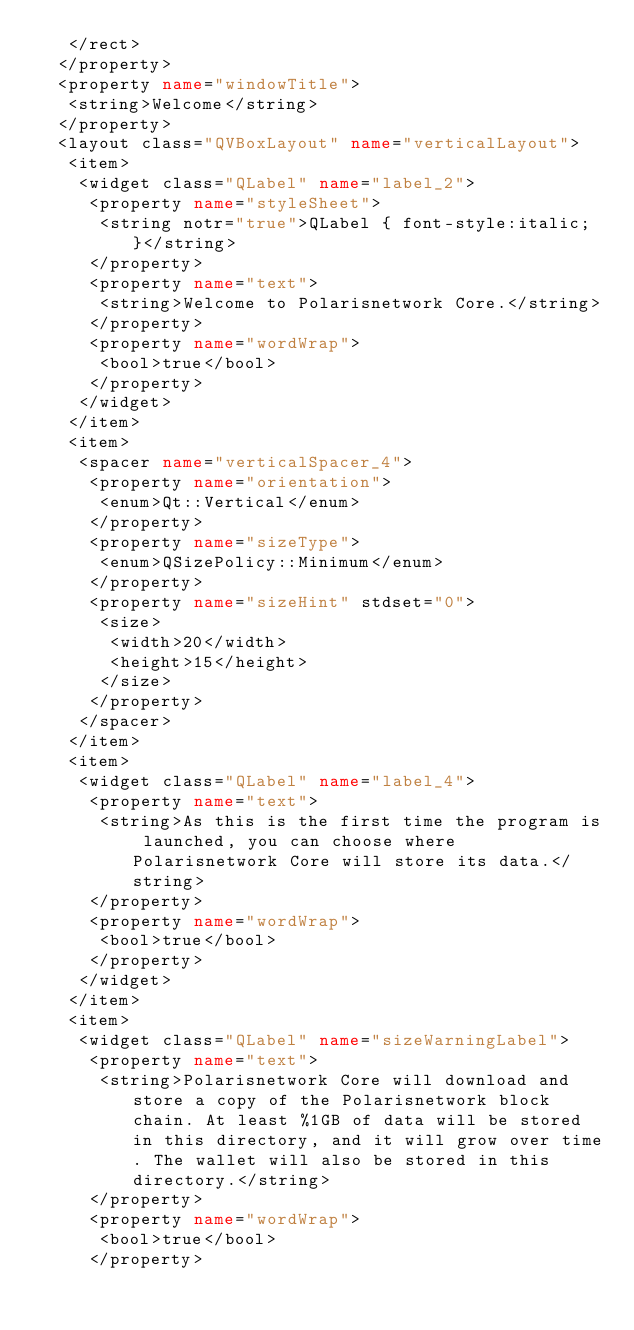Convert code to text. <code><loc_0><loc_0><loc_500><loc_500><_XML_>   </rect>
  </property>
  <property name="windowTitle">
   <string>Welcome</string>
  </property>
  <layout class="QVBoxLayout" name="verticalLayout">
   <item>
    <widget class="QLabel" name="label_2">
     <property name="styleSheet">
      <string notr="true">QLabel { font-style:italic; }</string>
     </property>
     <property name="text">
      <string>Welcome to Polarisnetwork Core.</string>
     </property>
     <property name="wordWrap">
      <bool>true</bool>
     </property>
    </widget>
   </item>
   <item>
    <spacer name="verticalSpacer_4">
     <property name="orientation">
      <enum>Qt::Vertical</enum>
     </property>
     <property name="sizeType">
      <enum>QSizePolicy::Minimum</enum>
     </property>
     <property name="sizeHint" stdset="0">
      <size>
       <width>20</width>
       <height>15</height>
      </size>
     </property>
    </spacer>
   </item>
   <item>
    <widget class="QLabel" name="label_4">
     <property name="text">
      <string>As this is the first time the program is launched, you can choose where Polarisnetwork Core will store its data.</string>
     </property>
     <property name="wordWrap">
      <bool>true</bool>
     </property>
    </widget>
   </item>
   <item>
    <widget class="QLabel" name="sizeWarningLabel">
     <property name="text">
      <string>Polarisnetwork Core will download and store a copy of the Polarisnetwork block chain. At least %1GB of data will be stored in this directory, and it will grow over time. The wallet will also be stored in this directory.</string>
     </property>
     <property name="wordWrap">
      <bool>true</bool>
     </property></code> 